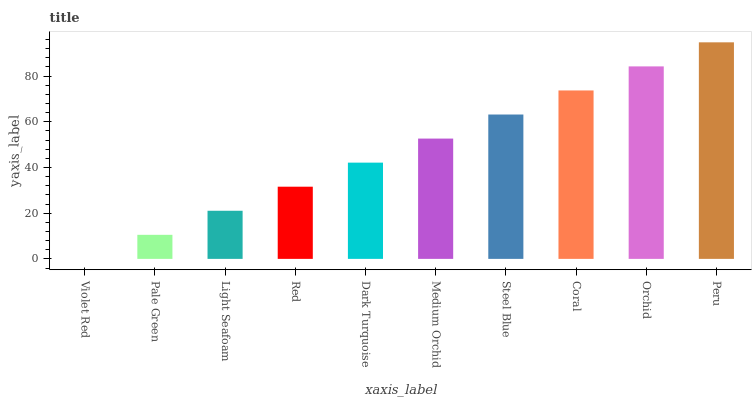Is Violet Red the minimum?
Answer yes or no. Yes. Is Peru the maximum?
Answer yes or no. Yes. Is Pale Green the minimum?
Answer yes or no. No. Is Pale Green the maximum?
Answer yes or no. No. Is Pale Green greater than Violet Red?
Answer yes or no. Yes. Is Violet Red less than Pale Green?
Answer yes or no. Yes. Is Violet Red greater than Pale Green?
Answer yes or no. No. Is Pale Green less than Violet Red?
Answer yes or no. No. Is Medium Orchid the high median?
Answer yes or no. Yes. Is Dark Turquoise the low median?
Answer yes or no. Yes. Is Violet Red the high median?
Answer yes or no. No. Is Peru the low median?
Answer yes or no. No. 